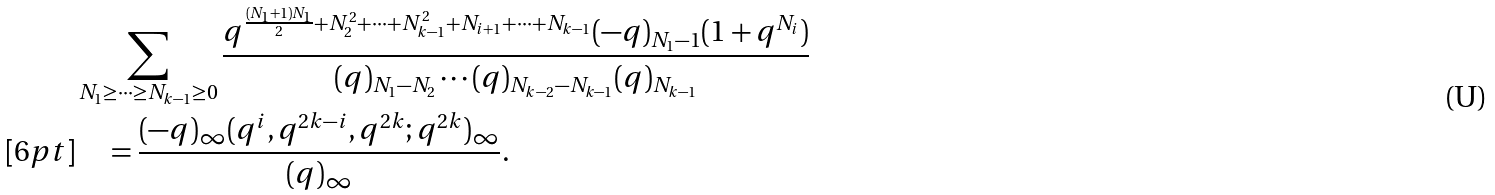<formula> <loc_0><loc_0><loc_500><loc_500>& \sum _ { N _ { 1 } \geq \cdots \geq N _ { k - 1 } \geq 0 } \frac { q ^ { \frac { ( N _ { 1 } + 1 ) N _ { 1 } } { 2 } + N _ { 2 } ^ { 2 } + \cdots + N _ { k - 1 } ^ { 2 } + N _ { i + 1 } + \cdots + N _ { k - 1 } } ( - q ) _ { N _ { 1 } - 1 } ( 1 + q ^ { N _ { i } } ) } { ( q ) _ { N _ { 1 } - N _ { 2 } } \cdots ( q ) _ { N _ { k - 2 } - N _ { k - 1 } } ( q ) _ { N _ { k - 1 } } } \\ [ 6 p t ] & \quad = \frac { ( - q ) _ { \infty } ( q ^ { i } , q ^ { 2 k - i } , q ^ { 2 k } ; q ^ { 2 k } ) _ { \infty } } { ( q ) _ { \infty } } .</formula> 